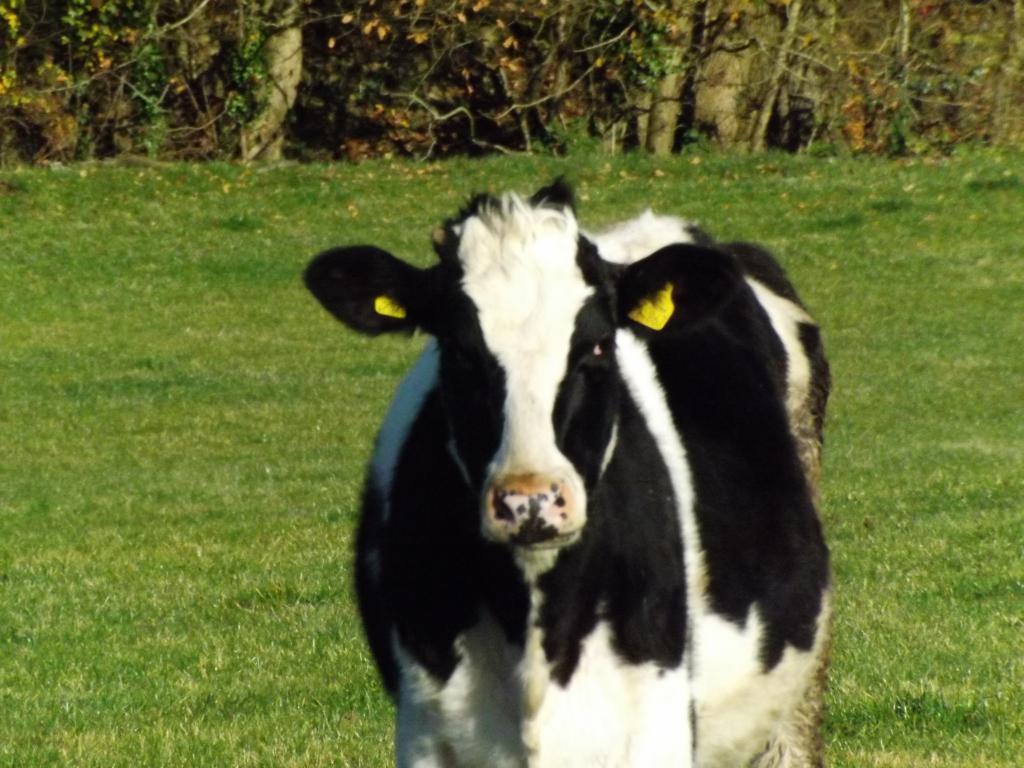Could you give a brief overview of what you see in this image? In this image I see a cow which is of white and black in color and in the background I see the green grass and I see plants over here. 